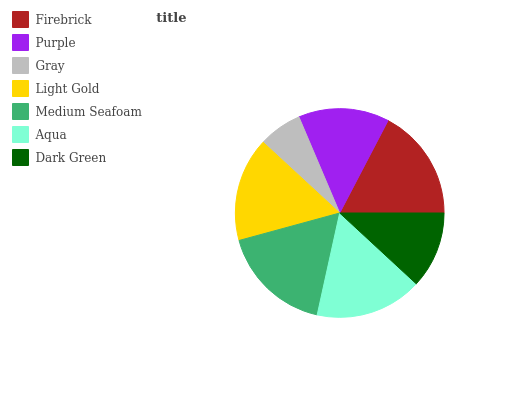Is Gray the minimum?
Answer yes or no. Yes. Is Firebrick the maximum?
Answer yes or no. Yes. Is Purple the minimum?
Answer yes or no. No. Is Purple the maximum?
Answer yes or no. No. Is Firebrick greater than Purple?
Answer yes or no. Yes. Is Purple less than Firebrick?
Answer yes or no. Yes. Is Purple greater than Firebrick?
Answer yes or no. No. Is Firebrick less than Purple?
Answer yes or no. No. Is Light Gold the high median?
Answer yes or no. Yes. Is Light Gold the low median?
Answer yes or no. Yes. Is Aqua the high median?
Answer yes or no. No. Is Gray the low median?
Answer yes or no. No. 